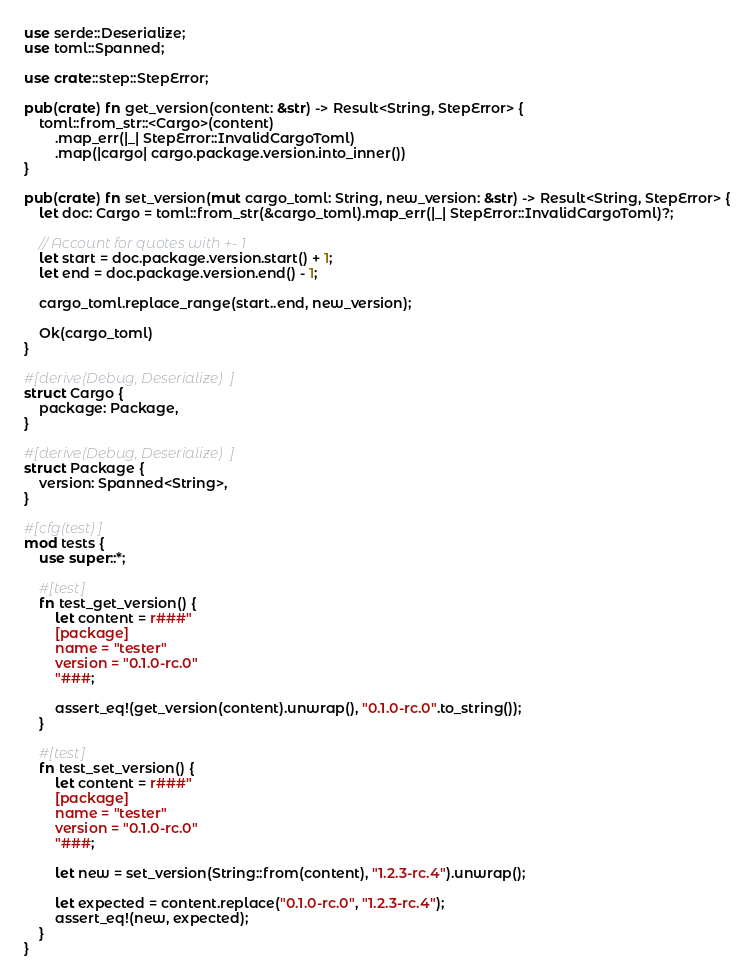<code> <loc_0><loc_0><loc_500><loc_500><_Rust_>use serde::Deserialize;
use toml::Spanned;

use crate::step::StepError;

pub(crate) fn get_version(content: &str) -> Result<String, StepError> {
    toml::from_str::<Cargo>(content)
        .map_err(|_| StepError::InvalidCargoToml)
        .map(|cargo| cargo.package.version.into_inner())
}

pub(crate) fn set_version(mut cargo_toml: String, new_version: &str) -> Result<String, StepError> {
    let doc: Cargo = toml::from_str(&cargo_toml).map_err(|_| StepError::InvalidCargoToml)?;

    // Account for quotes with +- 1
    let start = doc.package.version.start() + 1;
    let end = doc.package.version.end() - 1;

    cargo_toml.replace_range(start..end, new_version);

    Ok(cargo_toml)
}

#[derive(Debug, Deserialize)]
struct Cargo {
    package: Package,
}

#[derive(Debug, Deserialize)]
struct Package {
    version: Spanned<String>,
}

#[cfg(test)]
mod tests {
    use super::*;

    #[test]
    fn test_get_version() {
        let content = r###"
        [package]
        name = "tester"
        version = "0.1.0-rc.0"
        "###;

        assert_eq!(get_version(content).unwrap(), "0.1.0-rc.0".to_string());
    }

    #[test]
    fn test_set_version() {
        let content = r###"
        [package]
        name = "tester"
        version = "0.1.0-rc.0"
        "###;

        let new = set_version(String::from(content), "1.2.3-rc.4").unwrap();

        let expected = content.replace("0.1.0-rc.0", "1.2.3-rc.4");
        assert_eq!(new, expected);
    }
}
</code> 